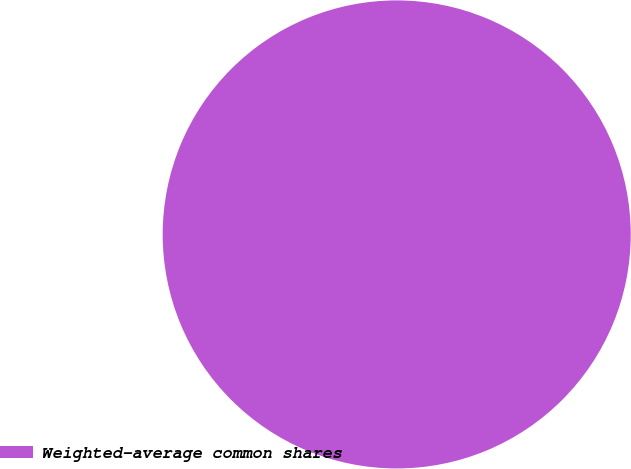<chart> <loc_0><loc_0><loc_500><loc_500><pie_chart><fcel>Weighted-average common shares<nl><fcel>100.0%<nl></chart> 